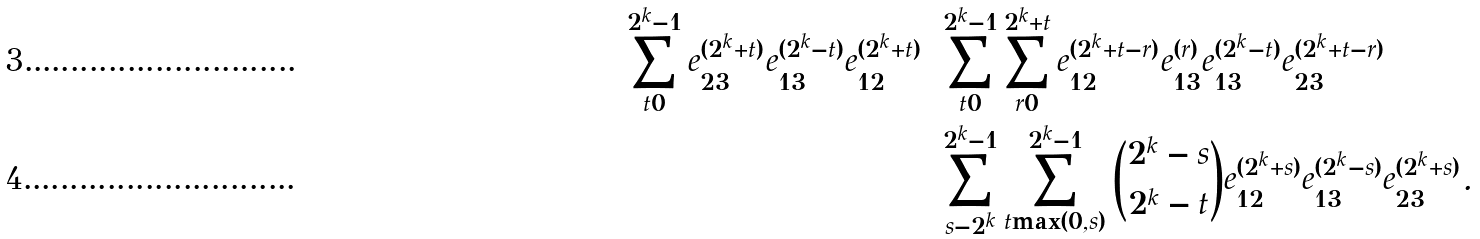<formula> <loc_0><loc_0><loc_500><loc_500>\sum _ { t = 0 } ^ { 2 ^ { k } - 1 } e _ { 2 3 } ^ { ( 2 ^ { k } + t ) } e _ { 1 3 } ^ { ( 2 ^ { k } - t ) } e _ { 1 2 } ^ { ( 2 ^ { k } + t ) } & = \sum _ { t = 0 } ^ { 2 ^ { k } - 1 } \sum _ { r = 0 } ^ { 2 ^ { k } + t } e _ { 1 2 } ^ { ( 2 ^ { k } + t - r ) } e _ { 1 3 } ^ { ( r ) } e _ { 1 3 } ^ { ( 2 ^ { k } - t ) } e _ { 2 3 } ^ { ( 2 ^ { k } + t - r ) } \\ & = \sum _ { s = - 2 ^ { k } } ^ { 2 ^ { k } - 1 } \sum _ { t = \max ( 0 , s ) } ^ { 2 ^ { k } - 1 } { 2 ^ { k } - s \choose 2 ^ { k } - t } e _ { 1 2 } ^ { ( 2 ^ { k } + s ) } e _ { 1 3 } ^ { ( 2 ^ { k } - s ) } e _ { 2 3 } ^ { ( 2 ^ { k } + s ) } .</formula> 